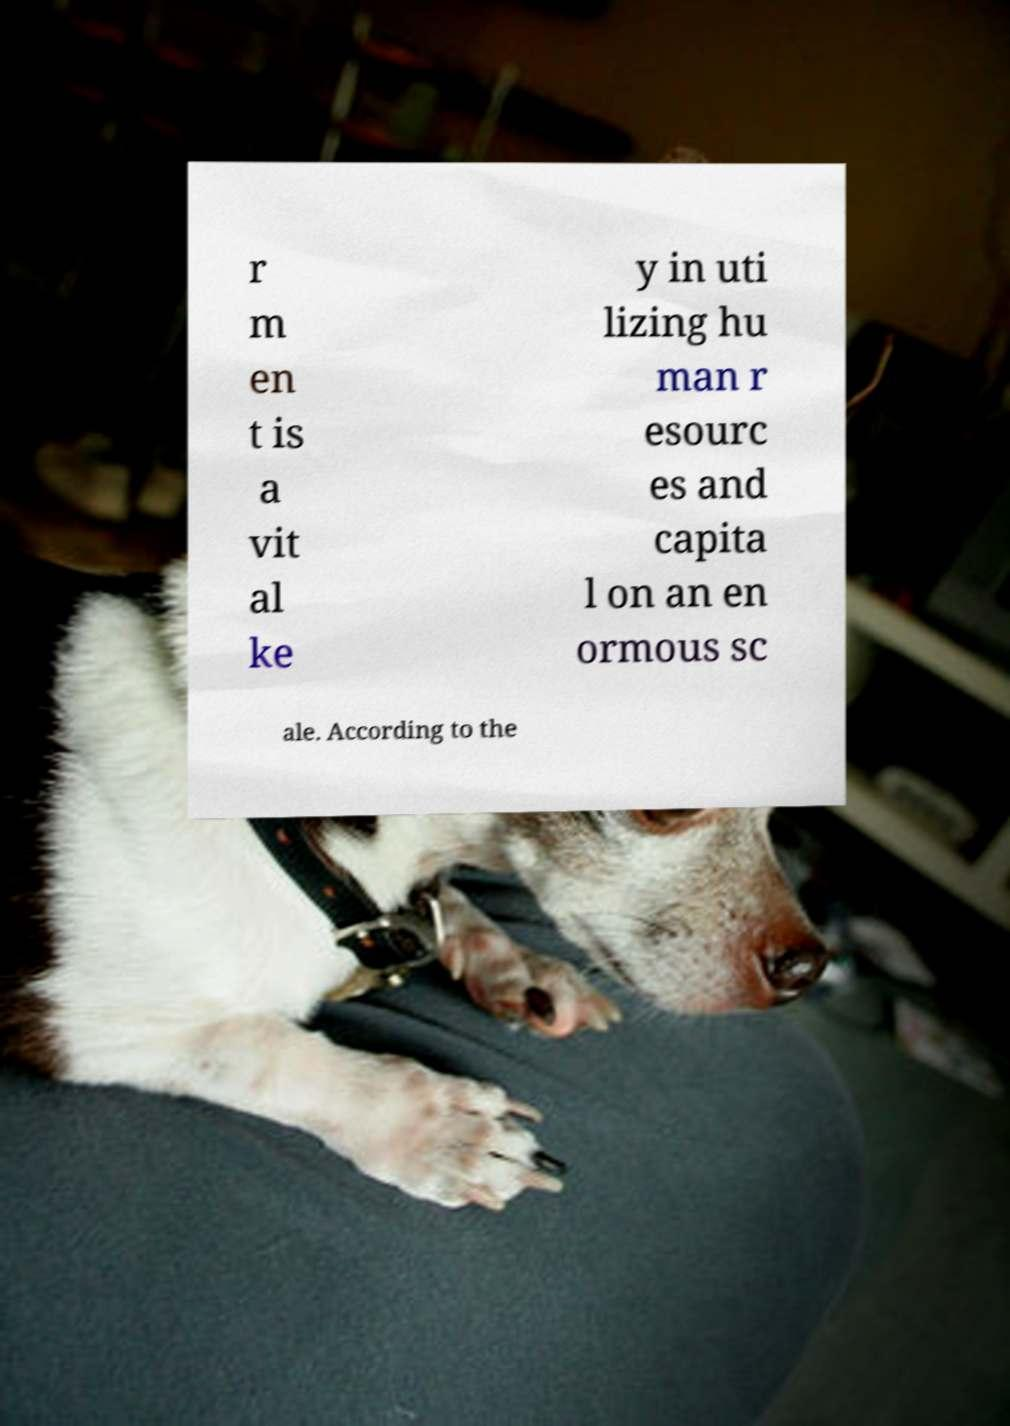Please read and relay the text visible in this image. What does it say? r m en t is a vit al ke y in uti lizing hu man r esourc es and capita l on an en ormous sc ale. According to the 